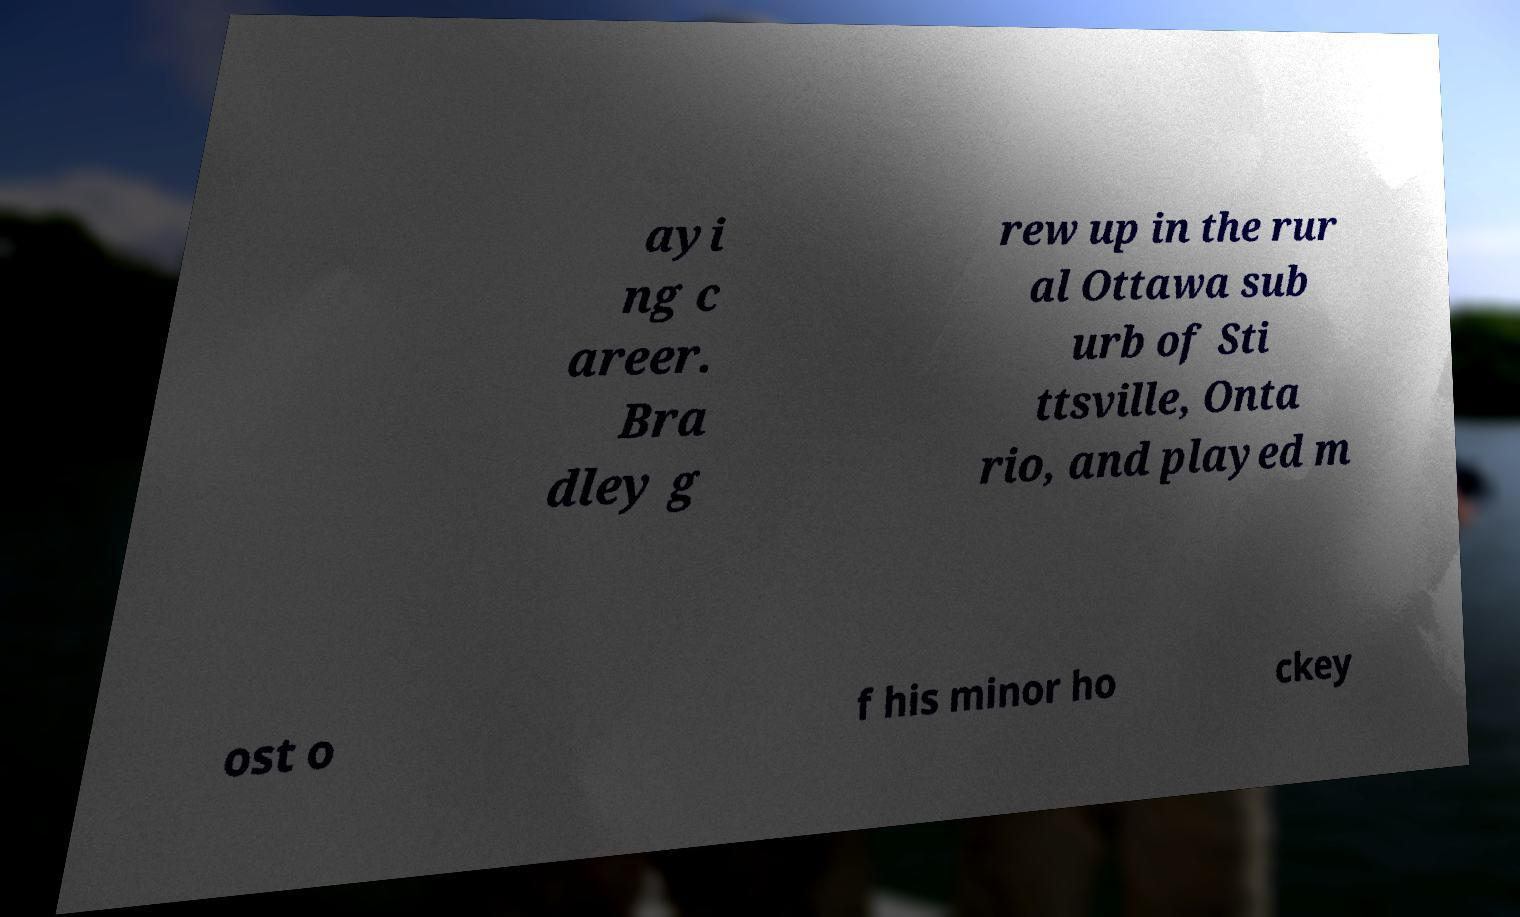Can you read and provide the text displayed in the image?This photo seems to have some interesting text. Can you extract and type it out for me? ayi ng c areer. Bra dley g rew up in the rur al Ottawa sub urb of Sti ttsville, Onta rio, and played m ost o f his minor ho ckey 